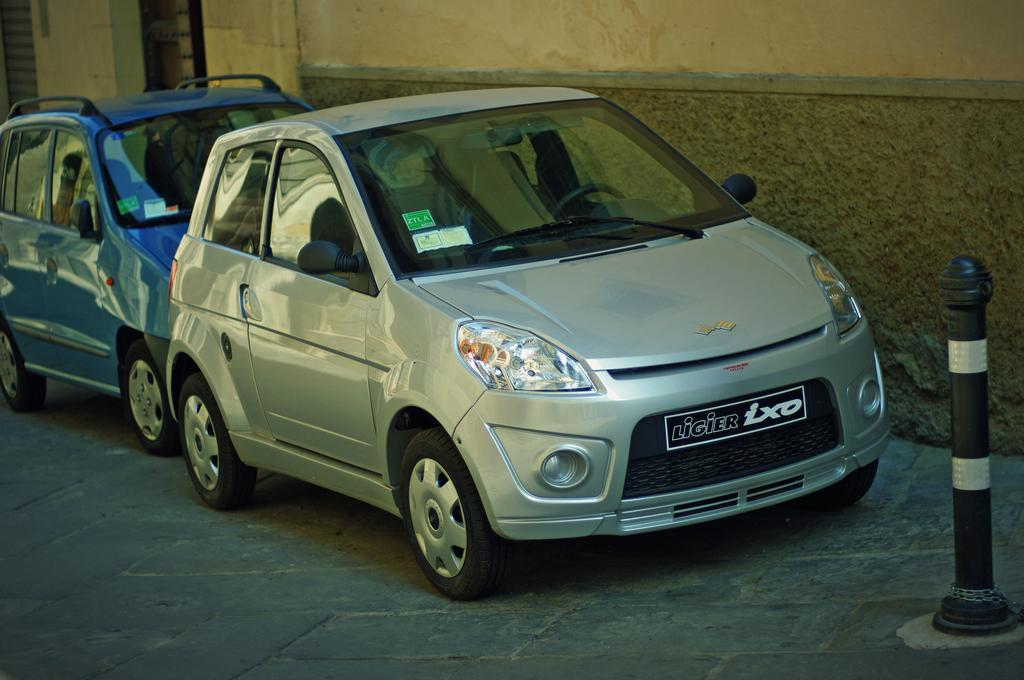What color is the car that is the main subject of the image? There is a silver-colored car in the image. Where is the silver-colored car located? The silver-colored car is on the pavement. What other car can be seen in the image? There is a blue-colored car behind the silver-colored car. What is on the right side of the image? There is a pole on the right side of the image. What is behind the pole? There is a wall behind the pole. Can you see any waves in the image? There are no waves present in the image; it features a silver-colored car, a blue-colored car, a pole, and a wall. What type of tool is being used to clean the sun in the image? There is no tool being used to clean the sun in the image, as the sun is not present. 